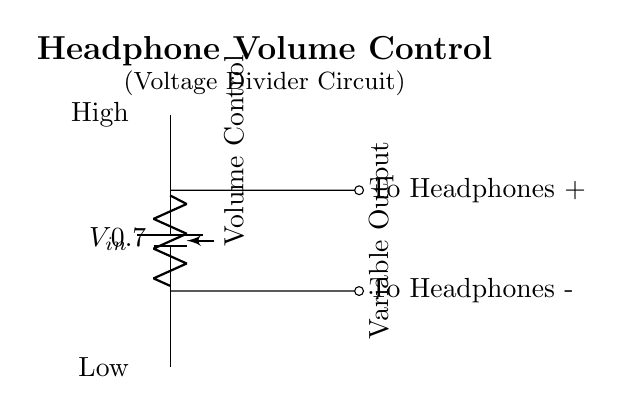What is the input voltage source in this circuit? The input voltage source is indicated as V in the circuit diagram, placed at the top.
Answer: V What is the purpose of the potentiometer in this circuit? The purpose of the potentiometer, labeled as Volume Control, is to adjust the resistance and, thus, control the volume output to the headphones.
Answer: Volume Control How many output points are there in the circuit? There are two output points, one for the positive side of the headphones and one for the negative side.
Answer: Two What is the relationship between the potentiometer and the output voltage? The potentiometer acts as a voltage divider, where its position determines the division of input voltage to create a variable output voltage for the headphones.
Answer: Variable output voltage If the potentiometer is turned to maximum resistance, what will happen to the volume? If the potentiometer is at maximum resistance, the output voltage will be minimal, resulting in very low volume or no sound.
Answer: Low volume Can this circuit work without the potentiometer? No, this circuit requires the potentiometer to function as a volume control; without it, sound cannot be adjusted.
Answer: No What is the significance of the labels "High" and "Low" beside the potentiometer? The labels indicate the range of resistance values for the potentiometer, where "High" corresponds to maximum resistance and "Low" corresponds to minimum resistance.
Answer: Resistance range 